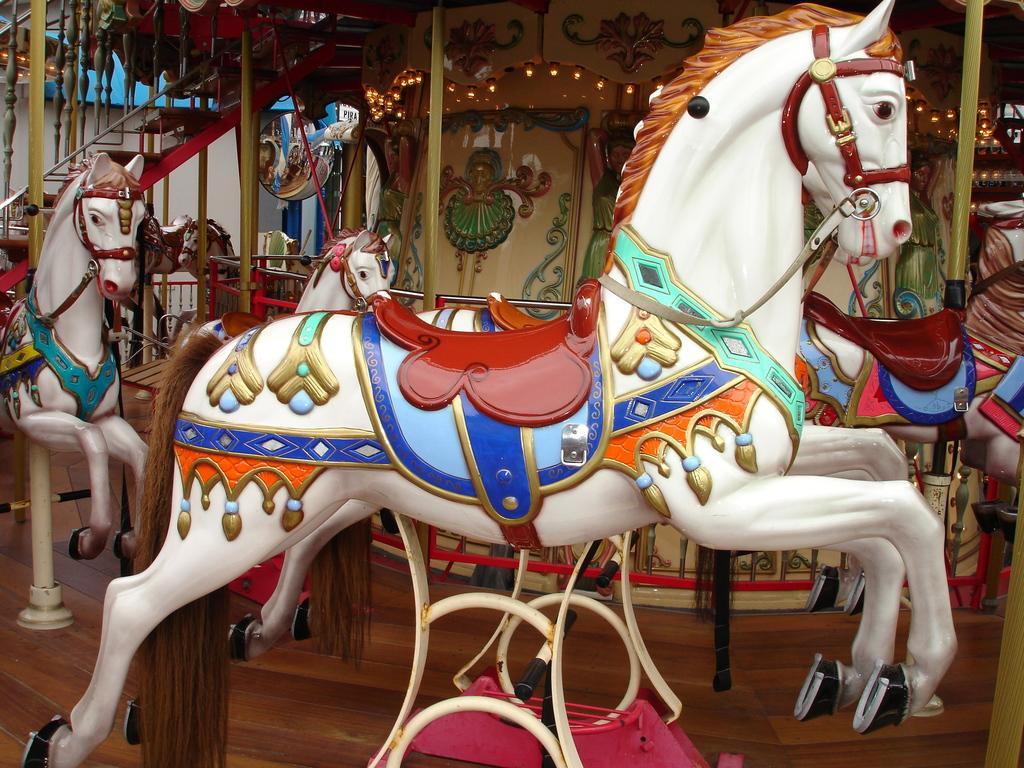How would you summarize this image in a sentence or two? There are few white color horse toys and there are some other objects in the background. 